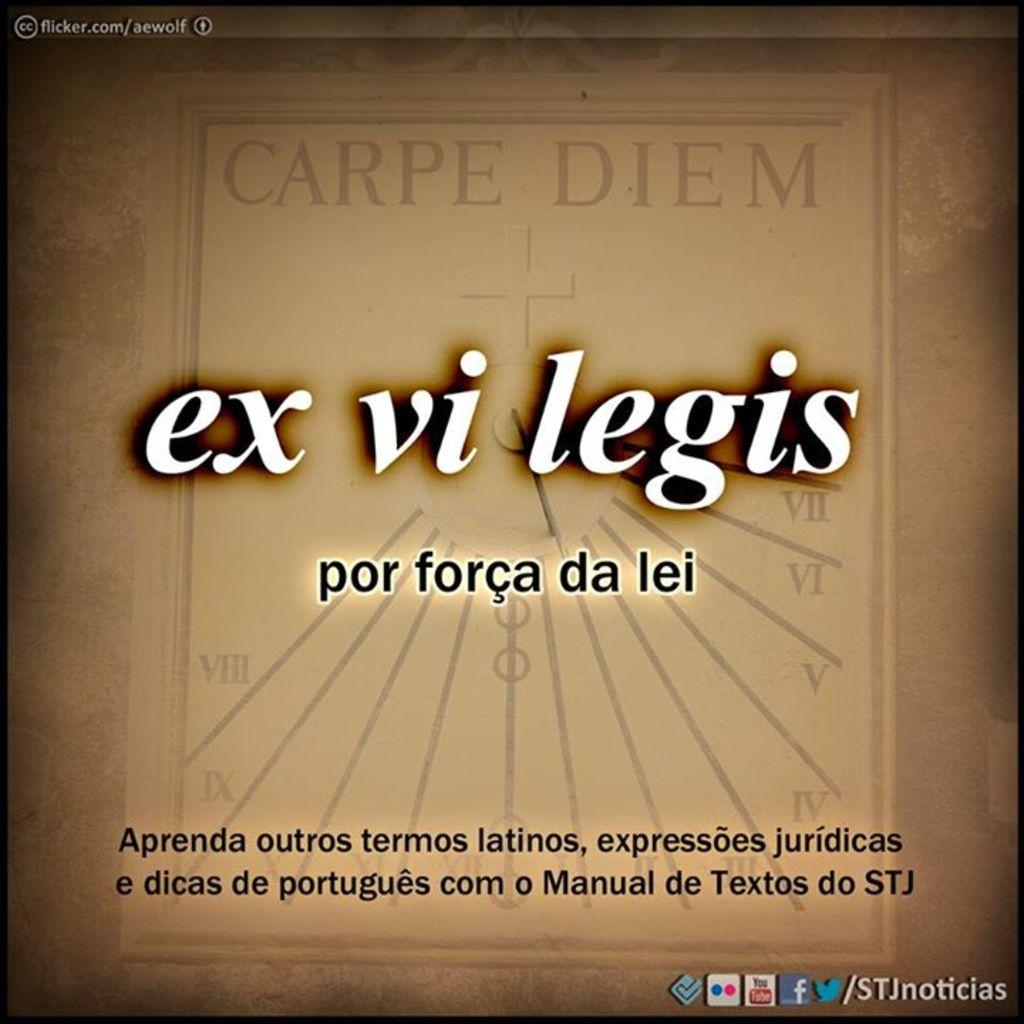<image>
Offer a succinct explanation of the picture presented. Foreign language advertisement on the computer for ex vi legis. 